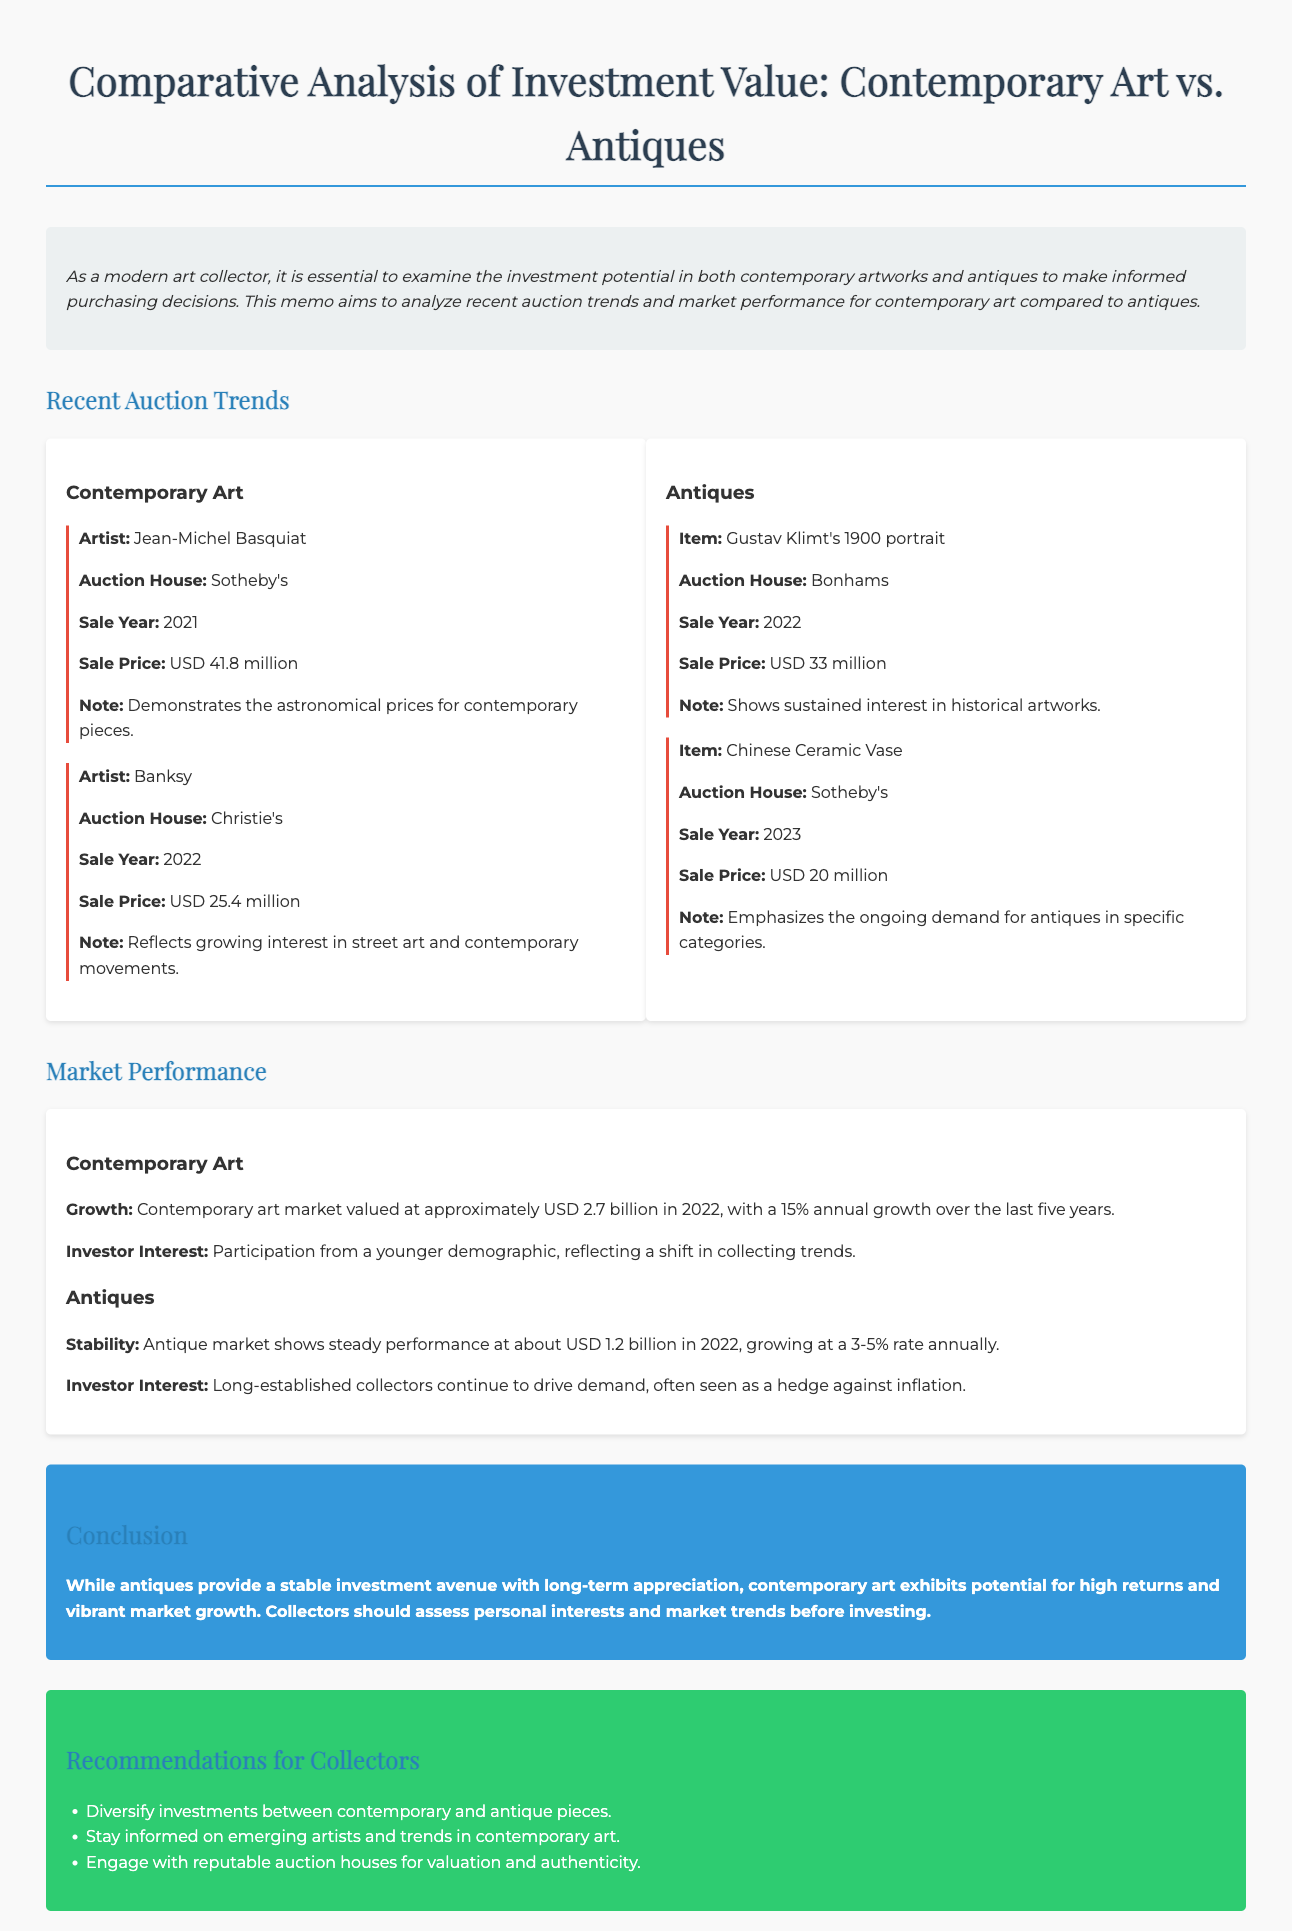what was the auction price of Jean-Michel Basquiat's artwork? The document states that Jean-Michel Basquiat's artwork sold for USD 41.8 million at Sotheby's in 2021.
Answer: USD 41.8 million who sold the Chinese Ceramic Vase? The document mentions that the Chinese Ceramic Vase was sold at Sotheby's.
Answer: Sotheby's what was the annual growth rate of the contemporary art market over the last five years? The memo indicates that the contemporary art market experienced a 15% annual growth over the last five years.
Answer: 15% what is the estimated value of the antique market in 2022? According to the document, the antique market was valued at about USD 1.2 billion in 2022.
Answer: USD 1.2 billion which artist's work reflects growing interest in street art? The memo refers to Banksy as an artist whose work reflects growing interest in street art.
Answer: Banksy how much did Gustav Klimt's 1900 portrait sell for? The document states that Gustav Klimt's 1900 portrait sold for USD 33 million at Bonhams in 2022.
Answer: USD 33 million what type of demographic is showing interest in contemporary art? The memo highlights investor interest from a younger demographic in contemporary art.
Answer: younger demographic what is a recommendation for collectors mentioned in the memo? The document recommends that collectors engage with reputable auction houses for valuation and authenticity.
Answer: engage with reputable auction houses 